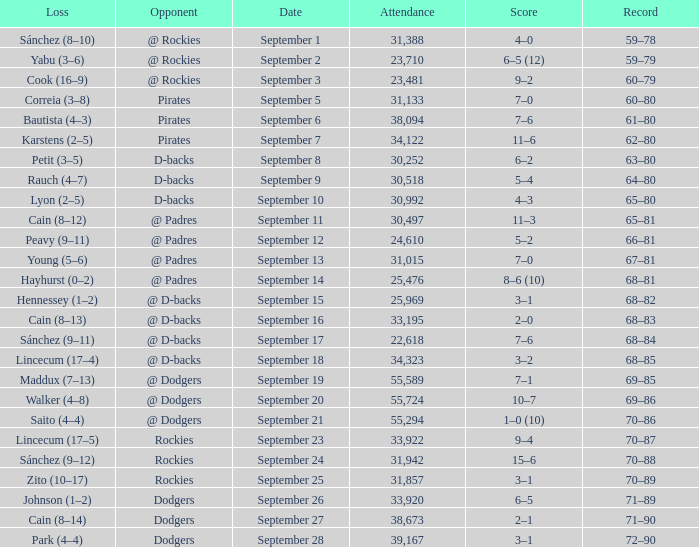What was the attendance on September 28? 39167.0. 